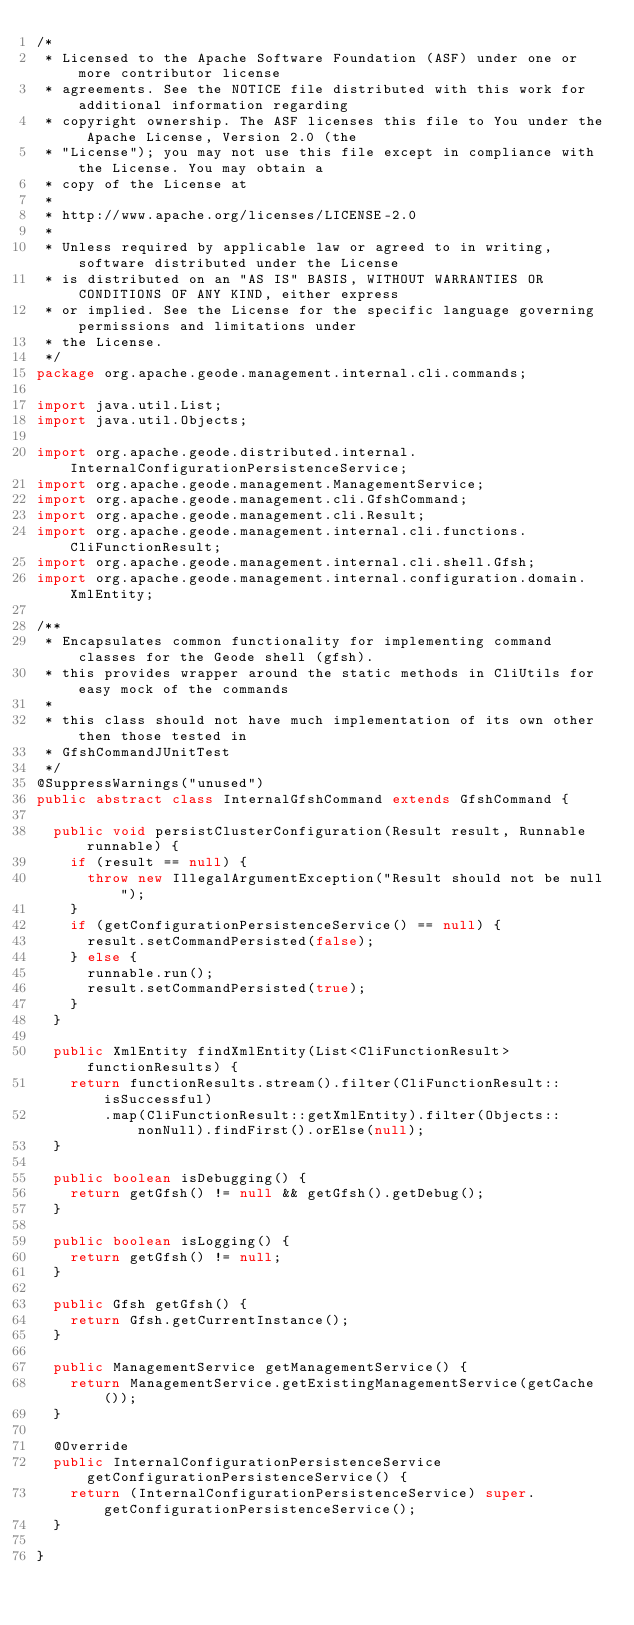Convert code to text. <code><loc_0><loc_0><loc_500><loc_500><_Java_>/*
 * Licensed to the Apache Software Foundation (ASF) under one or more contributor license
 * agreements. See the NOTICE file distributed with this work for additional information regarding
 * copyright ownership. The ASF licenses this file to You under the Apache License, Version 2.0 (the
 * "License"); you may not use this file except in compliance with the License. You may obtain a
 * copy of the License at
 *
 * http://www.apache.org/licenses/LICENSE-2.0
 *
 * Unless required by applicable law or agreed to in writing, software distributed under the License
 * is distributed on an "AS IS" BASIS, WITHOUT WARRANTIES OR CONDITIONS OF ANY KIND, either express
 * or implied. See the License for the specific language governing permissions and limitations under
 * the License.
 */
package org.apache.geode.management.internal.cli.commands;

import java.util.List;
import java.util.Objects;

import org.apache.geode.distributed.internal.InternalConfigurationPersistenceService;
import org.apache.geode.management.ManagementService;
import org.apache.geode.management.cli.GfshCommand;
import org.apache.geode.management.cli.Result;
import org.apache.geode.management.internal.cli.functions.CliFunctionResult;
import org.apache.geode.management.internal.cli.shell.Gfsh;
import org.apache.geode.management.internal.configuration.domain.XmlEntity;

/**
 * Encapsulates common functionality for implementing command classes for the Geode shell (gfsh).
 * this provides wrapper around the static methods in CliUtils for easy mock of the commands
 *
 * this class should not have much implementation of its own other then those tested in
 * GfshCommandJUnitTest
 */
@SuppressWarnings("unused")
public abstract class InternalGfshCommand extends GfshCommand {

  public void persistClusterConfiguration(Result result, Runnable runnable) {
    if (result == null) {
      throw new IllegalArgumentException("Result should not be null");
    }
    if (getConfigurationPersistenceService() == null) {
      result.setCommandPersisted(false);
    } else {
      runnable.run();
      result.setCommandPersisted(true);
    }
  }

  public XmlEntity findXmlEntity(List<CliFunctionResult> functionResults) {
    return functionResults.stream().filter(CliFunctionResult::isSuccessful)
        .map(CliFunctionResult::getXmlEntity).filter(Objects::nonNull).findFirst().orElse(null);
  }

  public boolean isDebugging() {
    return getGfsh() != null && getGfsh().getDebug();
  }

  public boolean isLogging() {
    return getGfsh() != null;
  }

  public Gfsh getGfsh() {
    return Gfsh.getCurrentInstance();
  }

  public ManagementService getManagementService() {
    return ManagementService.getExistingManagementService(getCache());
  }

  @Override
  public InternalConfigurationPersistenceService getConfigurationPersistenceService() {
    return (InternalConfigurationPersistenceService) super.getConfigurationPersistenceService();
  }

}
</code> 